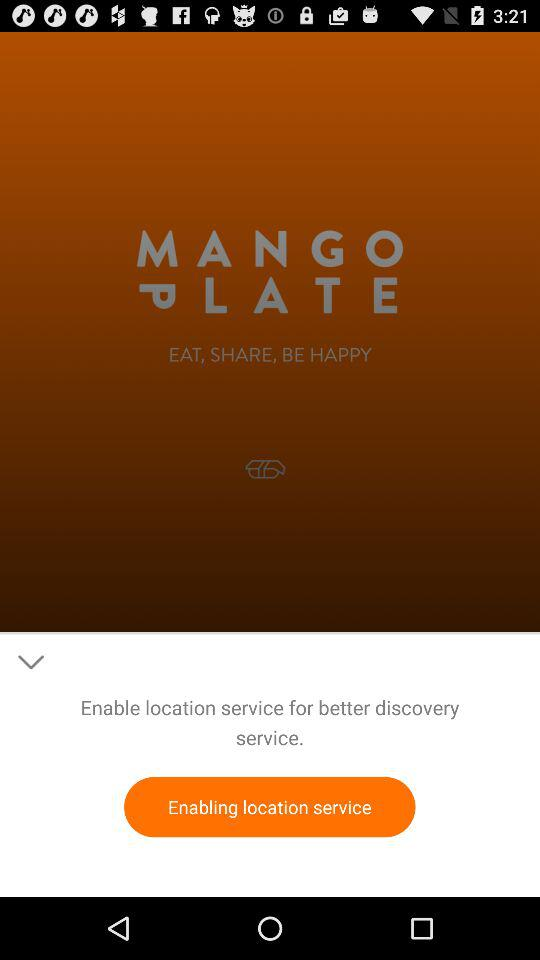What is the application name? The application name is "MangoPlate". 